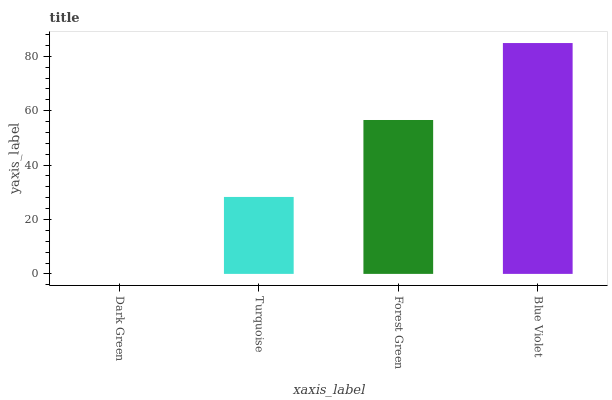Is Turquoise the minimum?
Answer yes or no. No. Is Turquoise the maximum?
Answer yes or no. No. Is Turquoise greater than Dark Green?
Answer yes or no. Yes. Is Dark Green less than Turquoise?
Answer yes or no. Yes. Is Dark Green greater than Turquoise?
Answer yes or no. No. Is Turquoise less than Dark Green?
Answer yes or no. No. Is Forest Green the high median?
Answer yes or no. Yes. Is Turquoise the low median?
Answer yes or no. Yes. Is Dark Green the high median?
Answer yes or no. No. Is Dark Green the low median?
Answer yes or no. No. 